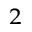Convert formula to latex. <formula><loc_0><loc_0><loc_500><loc_500>^ { 2 }</formula> 